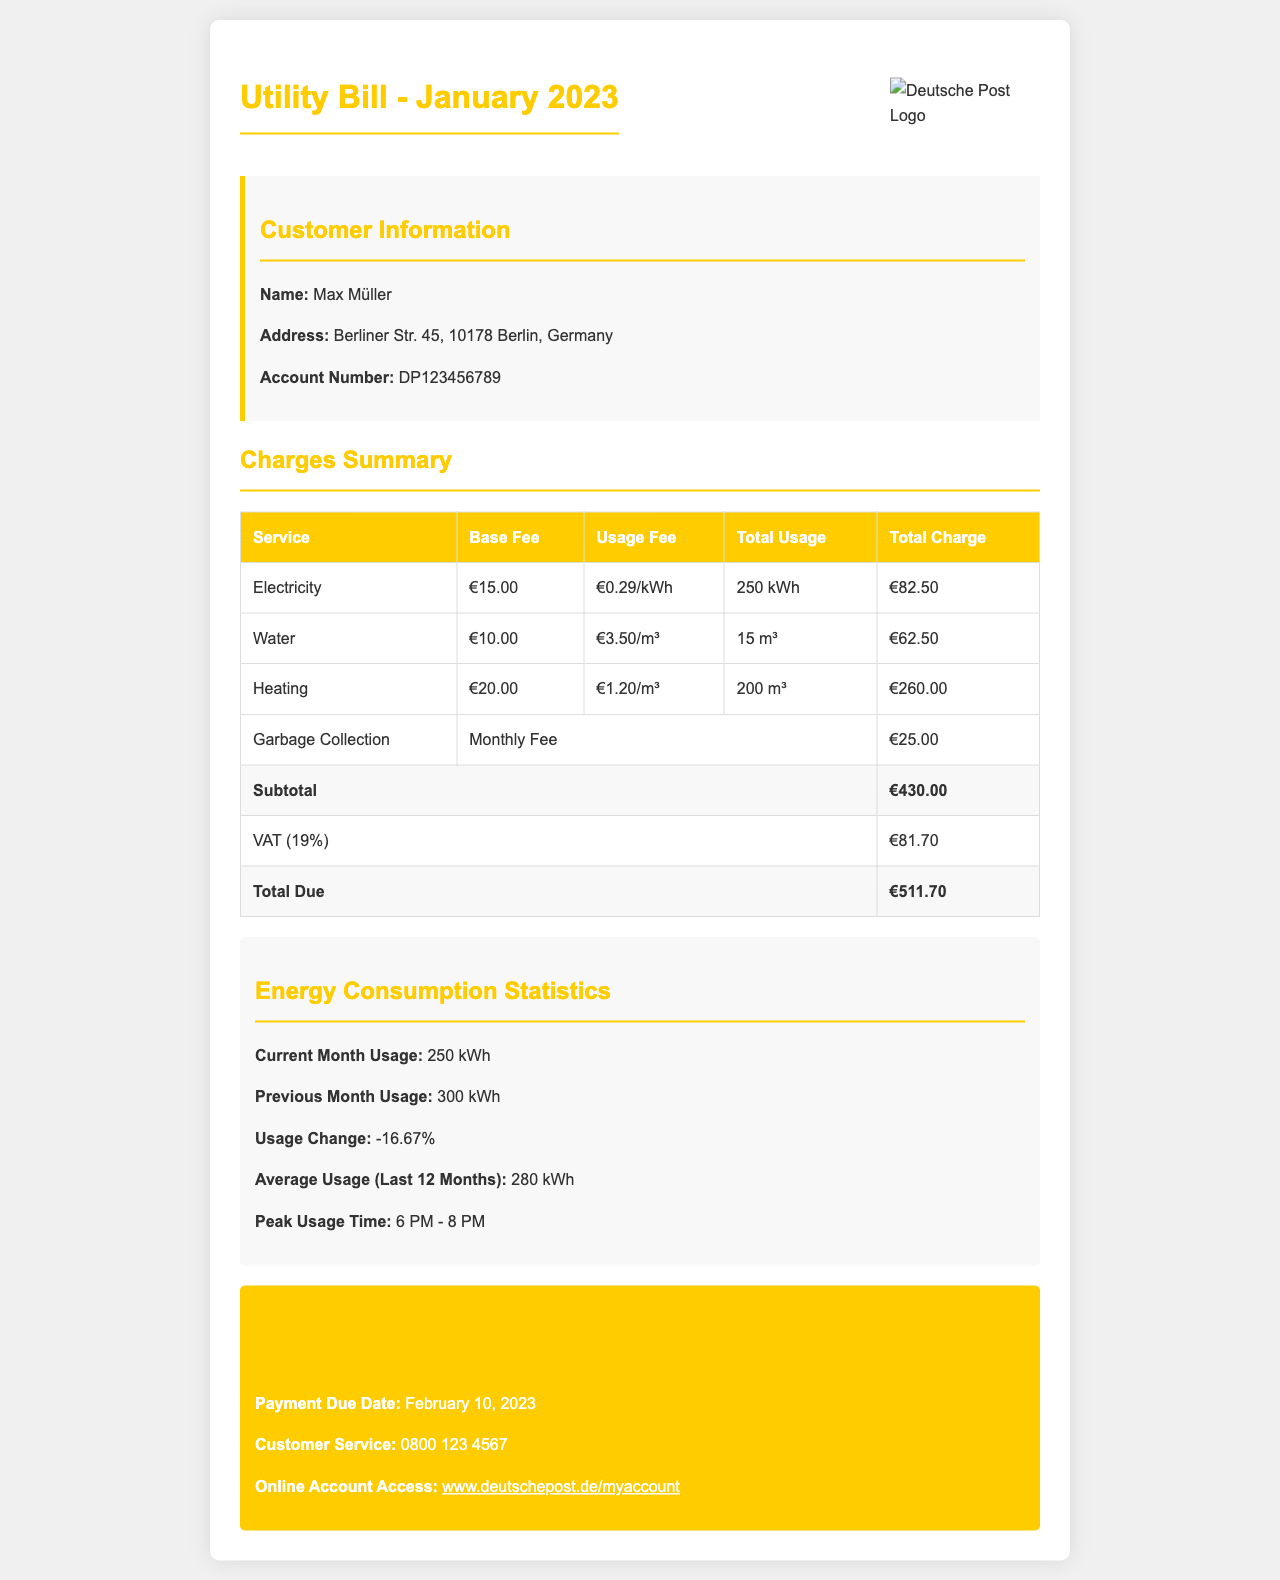What is the name of the customer? The customer's name is provided in the customer information section of the document.
Answer: Max Müller What is the total charge for electricity? The total charge for electricity is listed in the charges summary table.
Answer: €82.50 What is the total volume of water used? The total volume of water used is indicated in the charges summary table under total usage.
Answer: 15 m³ What is the VAT amount? The VAT amount is highlighted in the charges summary section as a separate line item.
Answer: €81.70 What is the payment due date? The payment due date is specified in the important information section of the document.
Answer: February 10, 2023 What was the previous month's electricity usage? The previous month's usage is found in the energy consumption statistics section.
Answer: 300 kWh What is the base fee for heating? The base fee for heating is shown in the charges summary table under base fee.
Answer: €20.00 What is the average usage over the last 12 months? The average usage is indicated in the energy consumption statistics section.
Answer: 280 kWh What time is peak usage recorded? The peak usage time is stated in the energy consumption statistics section.
Answer: 6 PM - 8 PM 